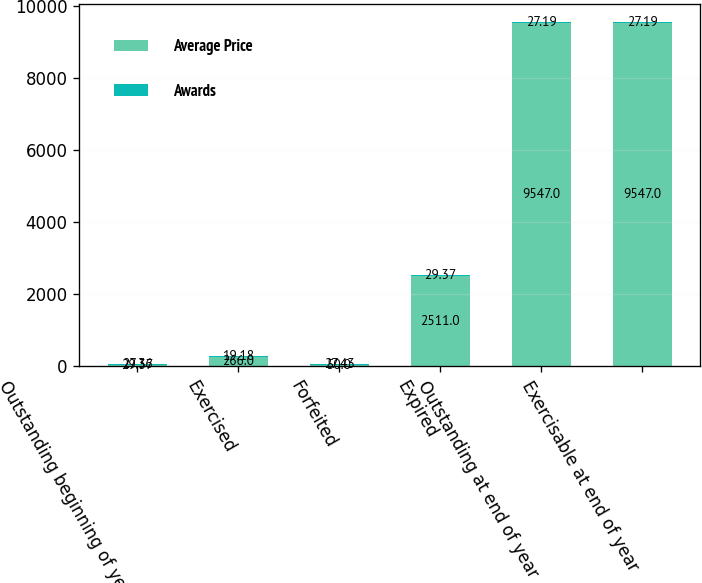Convert chart to OTSL. <chart><loc_0><loc_0><loc_500><loc_500><stacked_bar_chart><ecel><fcel>Outstanding beginning of year<fcel>Exercised<fcel>Forfeited<fcel>Expired<fcel>Outstanding at end of year<fcel>Exercisable at end of year<nl><fcel>Average Price<fcel>29.37<fcel>266<fcel>50<fcel>2511<fcel>9547<fcel>9547<nl><fcel>Awards<fcel>27.36<fcel>19.18<fcel>27.43<fcel>29.37<fcel>27.19<fcel>27.19<nl></chart> 